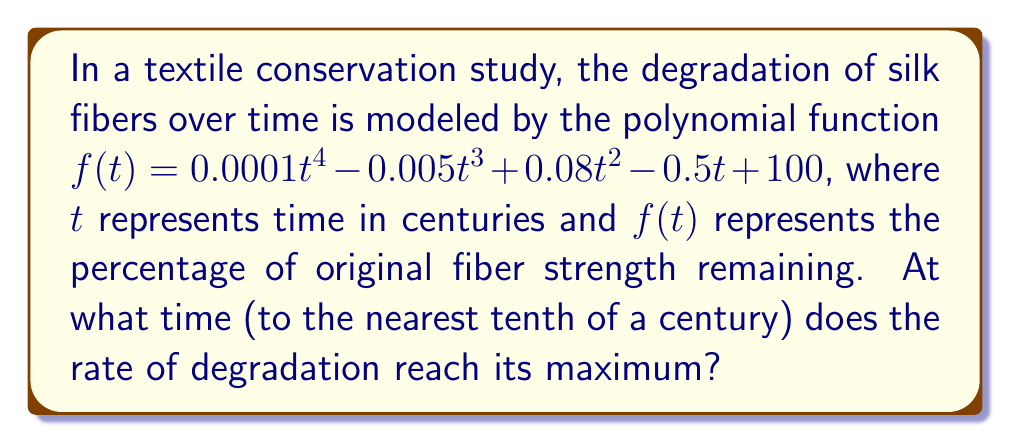What is the answer to this math problem? To find the time when the rate of degradation is at its maximum, we need to follow these steps:

1) The rate of degradation is represented by the negative of the first derivative of $f(t)$. So, we first find $f'(t)$:

   $f'(t) = 0.0004t^3 - 0.015t^2 + 0.16t - 0.5$

2) The maximum rate of degradation occurs when the second derivative of $f(t)$ is zero. So, we need to find $f''(t)$:

   $f''(t) = 0.0012t^2 - 0.03t + 0.16$

3) Set $f''(t) = 0$ and solve for $t$:

   $0.0012t^2 - 0.03t + 0.16 = 0$

4) This is a quadratic equation. We can solve it using the quadratic formula:

   $t = \frac{-b \pm \sqrt{b^2 - 4ac}}{2a}$

   Where $a = 0.0012$, $b = -0.03$, and $c = 0.16$

5) Substituting these values:

   $t = \frac{0.03 \pm \sqrt{(-0.03)^2 - 4(0.0012)(0.16)}}{2(0.0012)}$

6) Simplifying:

   $t = \frac{0.03 \pm \sqrt{0.0009 - 0.000768}}{0.0024}$
   $t = \frac{0.03 \pm \sqrt{0.000132}}{0.0024}$
   $t = \frac{0.03 \pm 0.011489}{0.0024}$

7) This gives us two solutions:

   $t_1 = \frac{0.03 + 0.011489}{0.0024} \approx 17.29$
   $t_2 = \frac{0.03 - 0.011489}{0.0024} \approx 7.71$

8) Since we're looking for the maximum rate of degradation, we choose the smaller value, as degradation typically increases more rapidly in earlier stages.

9) Rounding to the nearest tenth of a century:

   $7.71 \approx 7.7$ centuries
Answer: 7.7 centuries 